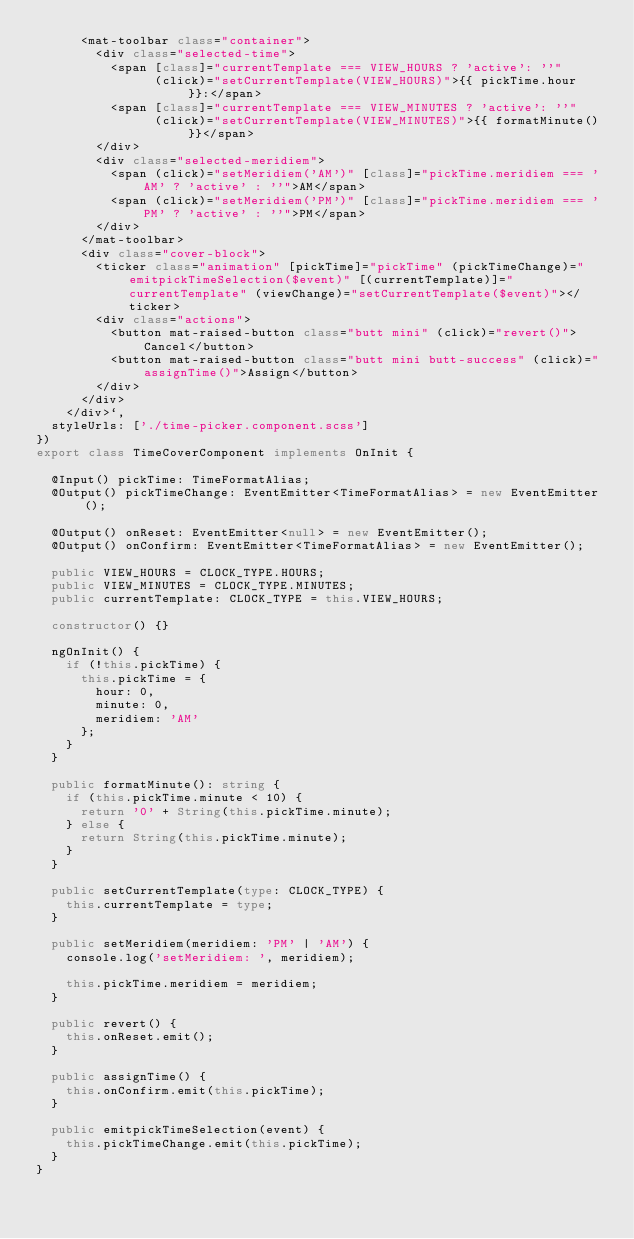Convert code to text. <code><loc_0><loc_0><loc_500><loc_500><_TypeScript_>      <mat-toolbar class="container">
        <div class="selected-time">
          <span [class]="currentTemplate === VIEW_HOURS ? 'active': ''"
                (click)="setCurrentTemplate(VIEW_HOURS)">{{ pickTime.hour }}:</span>
          <span [class]="currentTemplate === VIEW_MINUTES ? 'active': ''"
                (click)="setCurrentTemplate(VIEW_MINUTES)">{{ formatMinute() }}</span>
        </div>
        <div class="selected-meridiem">
          <span (click)="setMeridiem('AM')" [class]="pickTime.meridiem === 'AM' ? 'active' : ''">AM</span>
          <span (click)="setMeridiem('PM')" [class]="pickTime.meridiem === 'PM' ? 'active' : ''">PM</span>
        </div>
      </mat-toolbar>
      <div class="cover-block">
        <ticker class="animation" [pickTime]="pickTime" (pickTimeChange)="emitpickTimeSelection($event)" [(currentTemplate)]="currentTemplate" (viewChange)="setCurrentTemplate($event)"></ticker>
        <div class="actions">
          <button mat-raised-button class="butt mini" (click)="revert()">Cancel</button>
          <button mat-raised-button class="butt mini butt-success" (click)="assignTime()">Assign</button>
        </div>
      </div>
    </div>`,
  styleUrls: ['./time-picker.component.scss']
})
export class TimeCoverComponent implements OnInit {

  @Input() pickTime: TimeFormatAlias;
  @Output() pickTimeChange: EventEmitter<TimeFormatAlias> = new EventEmitter();

  @Output() onReset: EventEmitter<null> = new EventEmitter();
  @Output() onConfirm: EventEmitter<TimeFormatAlias> = new EventEmitter();

  public VIEW_HOURS = CLOCK_TYPE.HOURS;
  public VIEW_MINUTES = CLOCK_TYPE.MINUTES;
  public currentTemplate: CLOCK_TYPE = this.VIEW_HOURS;

  constructor() {}

  ngOnInit() {
    if (!this.pickTime) {
      this.pickTime = {
        hour: 0,
        minute: 0,
        meridiem: 'AM'
      };
    }
  }

  public formatMinute(): string {
    if (this.pickTime.minute < 10) {
      return '0' + String(this.pickTime.minute);
    } else {
      return String(this.pickTime.minute);
    }
  }

  public setCurrentTemplate(type: CLOCK_TYPE) {
    this.currentTemplate = type;
  }

  public setMeridiem(meridiem: 'PM' | 'AM') {
    console.log('setMeridiem: ', meridiem);

    this.pickTime.meridiem = meridiem;
  }

  public revert() {
    this.onReset.emit();
  }

  public assignTime() {
    this.onConfirm.emit(this.pickTime);
  }

  public emitpickTimeSelection(event) {
    this.pickTimeChange.emit(this.pickTime);
  }
}
</code> 